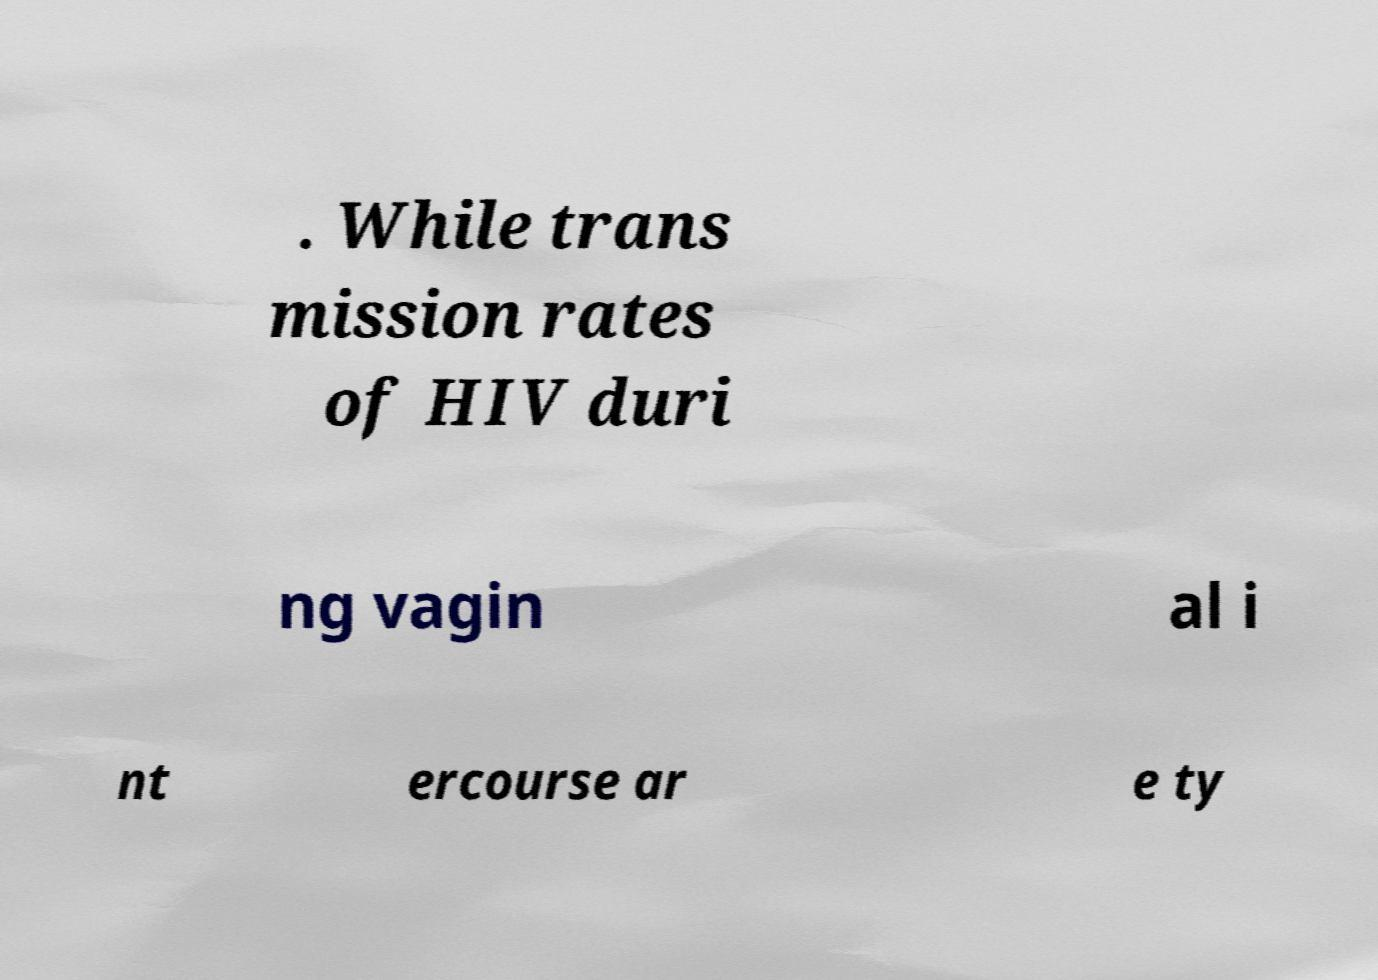Please read and relay the text visible in this image. What does it say? . While trans mission rates of HIV duri ng vagin al i nt ercourse ar e ty 